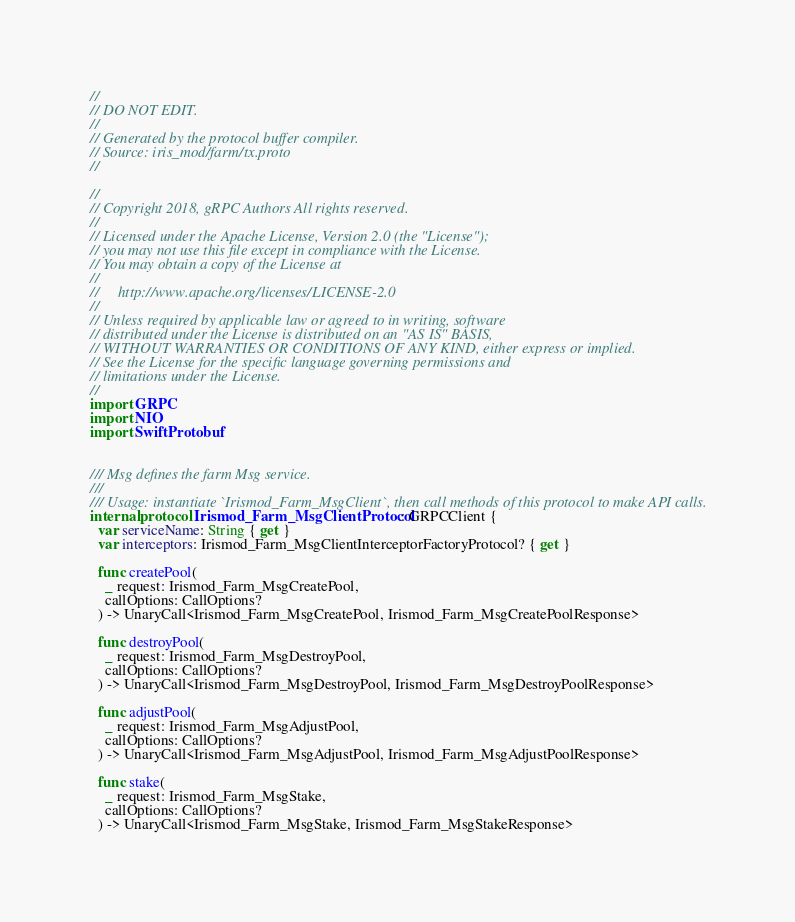Convert code to text. <code><loc_0><loc_0><loc_500><loc_500><_Swift_>//
// DO NOT EDIT.
//
// Generated by the protocol buffer compiler.
// Source: iris_mod/farm/tx.proto
//

//
// Copyright 2018, gRPC Authors All rights reserved.
//
// Licensed under the Apache License, Version 2.0 (the "License");
// you may not use this file except in compliance with the License.
// You may obtain a copy of the License at
//
//     http://www.apache.org/licenses/LICENSE-2.0
//
// Unless required by applicable law or agreed to in writing, software
// distributed under the License is distributed on an "AS IS" BASIS,
// WITHOUT WARRANTIES OR CONDITIONS OF ANY KIND, either express or implied.
// See the License for the specific language governing permissions and
// limitations under the License.
//
import GRPC
import NIO
import SwiftProtobuf


/// Msg defines the farm Msg service.
///
/// Usage: instantiate `Irismod_Farm_MsgClient`, then call methods of this protocol to make API calls.
internal protocol Irismod_Farm_MsgClientProtocol: GRPCClient {
  var serviceName: String { get }
  var interceptors: Irismod_Farm_MsgClientInterceptorFactoryProtocol? { get }

  func createPool(
    _ request: Irismod_Farm_MsgCreatePool,
    callOptions: CallOptions?
  ) -> UnaryCall<Irismod_Farm_MsgCreatePool, Irismod_Farm_MsgCreatePoolResponse>

  func destroyPool(
    _ request: Irismod_Farm_MsgDestroyPool,
    callOptions: CallOptions?
  ) -> UnaryCall<Irismod_Farm_MsgDestroyPool, Irismod_Farm_MsgDestroyPoolResponse>

  func adjustPool(
    _ request: Irismod_Farm_MsgAdjustPool,
    callOptions: CallOptions?
  ) -> UnaryCall<Irismod_Farm_MsgAdjustPool, Irismod_Farm_MsgAdjustPoolResponse>

  func stake(
    _ request: Irismod_Farm_MsgStake,
    callOptions: CallOptions?
  ) -> UnaryCall<Irismod_Farm_MsgStake, Irismod_Farm_MsgStakeResponse>
</code> 